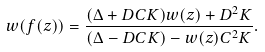<formula> <loc_0><loc_0><loc_500><loc_500>w ( f ( z ) ) = \frac { ( \Delta + D C K ) w ( z ) + D ^ { 2 } K } { ( \Delta - D C K ) - w ( z ) C ^ { 2 } K } .</formula> 